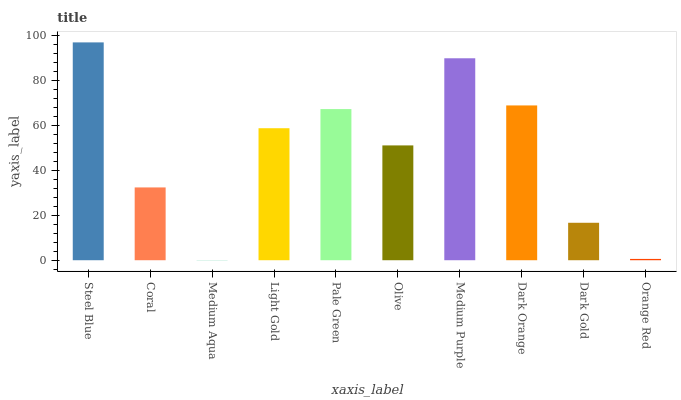Is Medium Aqua the minimum?
Answer yes or no. Yes. Is Steel Blue the maximum?
Answer yes or no. Yes. Is Coral the minimum?
Answer yes or no. No. Is Coral the maximum?
Answer yes or no. No. Is Steel Blue greater than Coral?
Answer yes or no. Yes. Is Coral less than Steel Blue?
Answer yes or no. Yes. Is Coral greater than Steel Blue?
Answer yes or no. No. Is Steel Blue less than Coral?
Answer yes or no. No. Is Light Gold the high median?
Answer yes or no. Yes. Is Olive the low median?
Answer yes or no. Yes. Is Coral the high median?
Answer yes or no. No. Is Coral the low median?
Answer yes or no. No. 